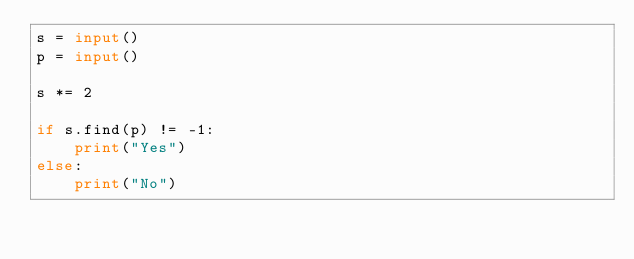<code> <loc_0><loc_0><loc_500><loc_500><_Python_>s = input()
p = input()

s *= 2

if s.find(p) != -1:
    print("Yes")
else:
    print("No")</code> 